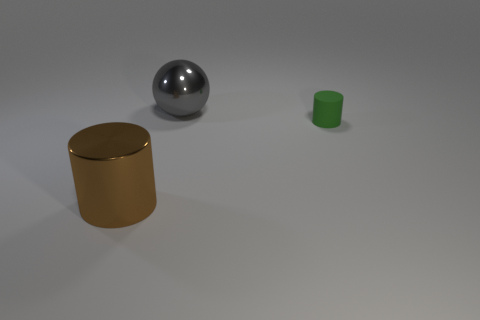Subtract all green cylinders. How many cylinders are left? 1 Add 3 brown shiny objects. How many objects exist? 6 Subtract 0 brown cubes. How many objects are left? 3 Subtract all cylinders. How many objects are left? 1 Subtract 1 cylinders. How many cylinders are left? 1 Subtract all cyan cylinders. Subtract all yellow balls. How many cylinders are left? 2 Subtract all brown cylinders. How many green balls are left? 0 Subtract all big gray metal things. Subtract all large cyan matte cubes. How many objects are left? 2 Add 1 big gray shiny objects. How many big gray shiny objects are left? 2 Add 2 gray rubber cylinders. How many gray rubber cylinders exist? 2 